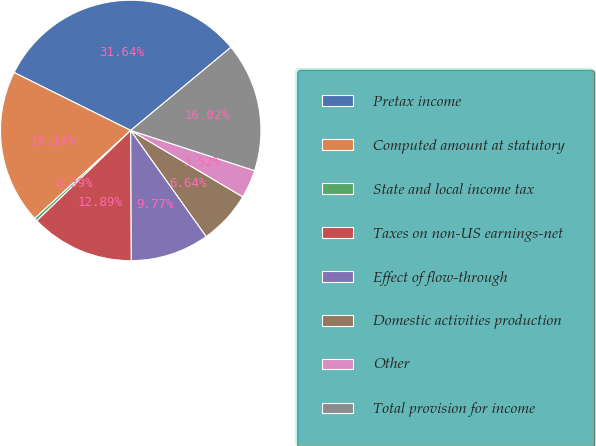<chart> <loc_0><loc_0><loc_500><loc_500><pie_chart><fcel>Pretax income<fcel>Computed amount at statutory<fcel>State and local income tax<fcel>Taxes on non-US earnings-net<fcel>Effect of flow-through<fcel>Domestic activities production<fcel>Other<fcel>Total provision for income<nl><fcel>31.64%<fcel>19.14%<fcel>0.39%<fcel>12.89%<fcel>9.77%<fcel>6.64%<fcel>3.52%<fcel>16.02%<nl></chart> 